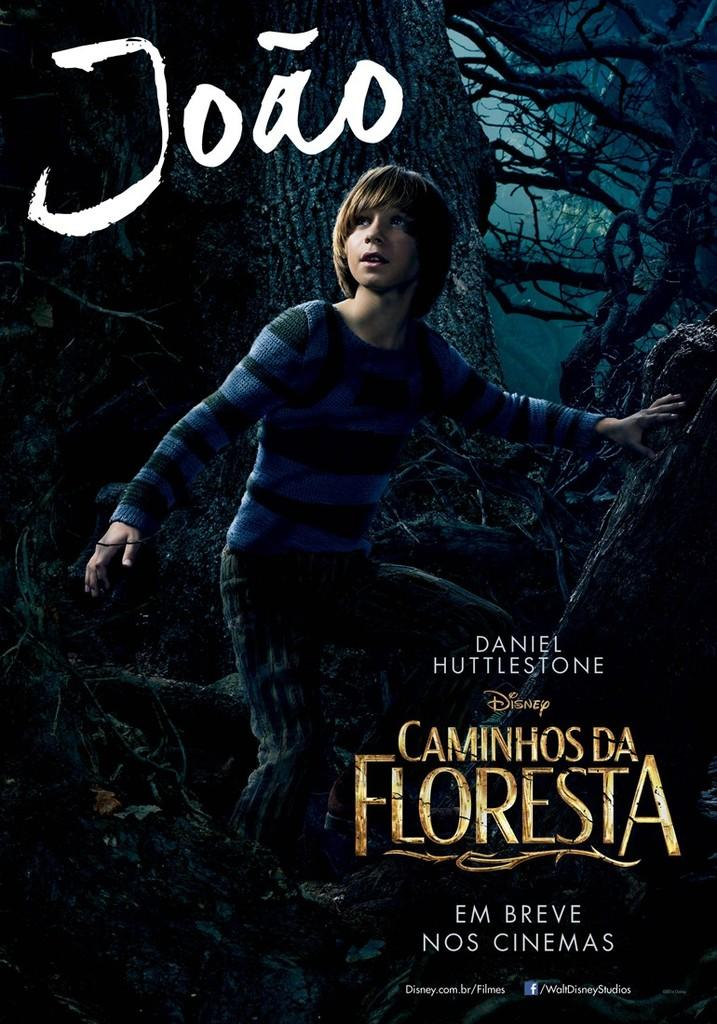<image>
Relay a brief, clear account of the picture shown. A movie posted for Disney's Caminhos da floresta. 